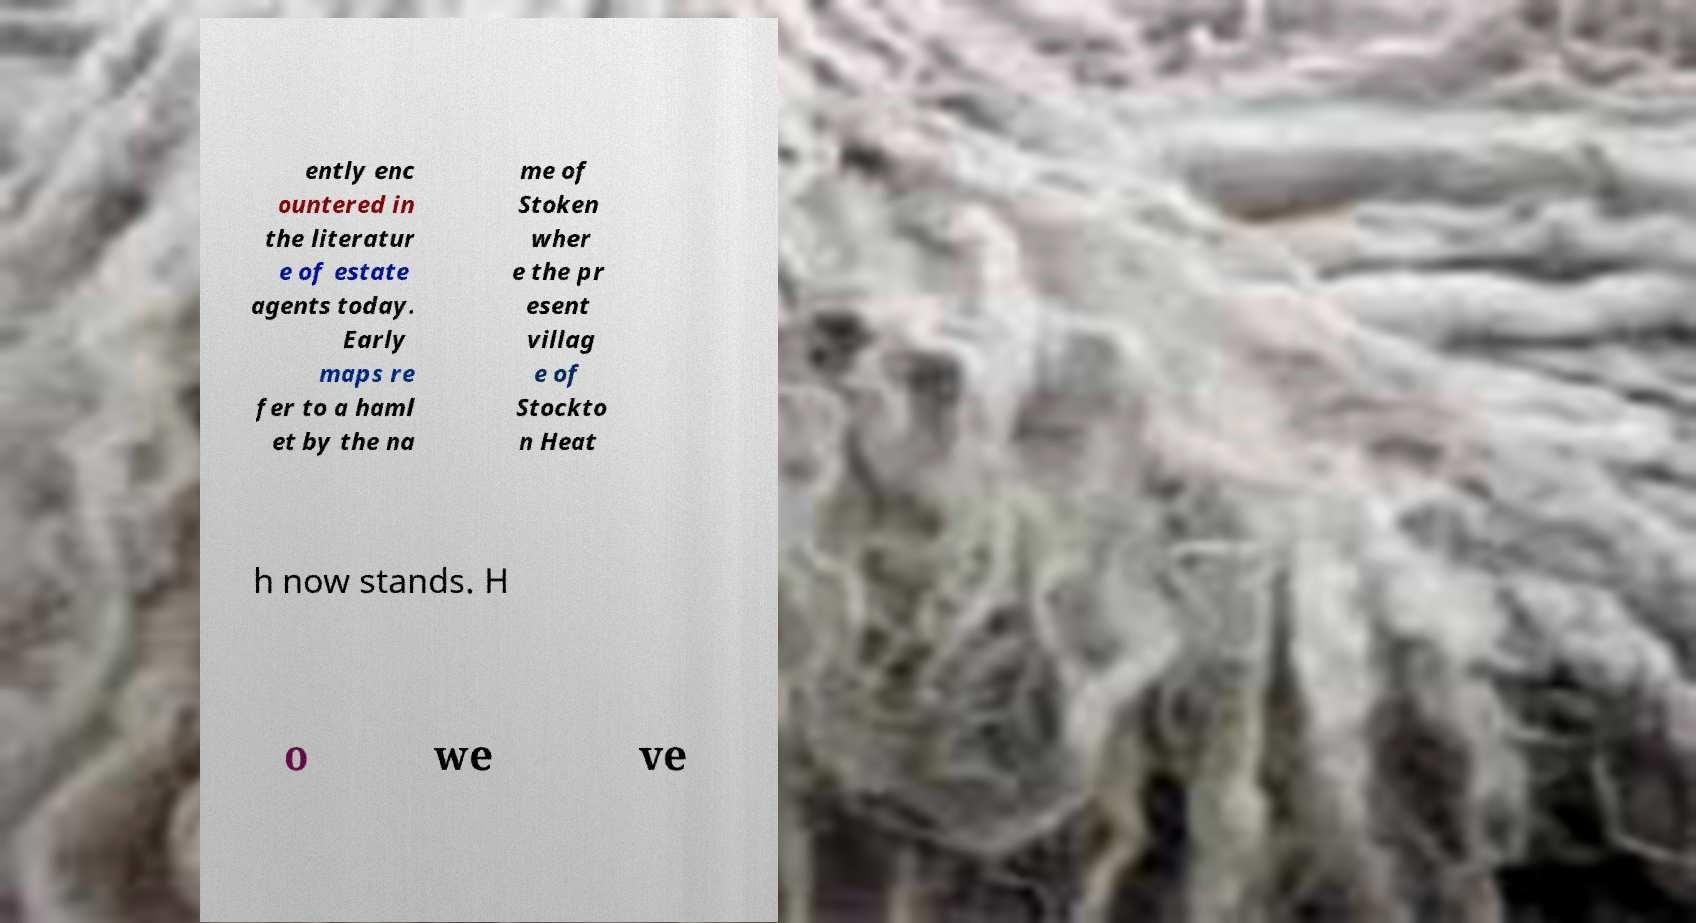I need the written content from this picture converted into text. Can you do that? ently enc ountered in the literatur e of estate agents today. Early maps re fer to a haml et by the na me of Stoken wher e the pr esent villag e of Stockto n Heat h now stands. H o we ve 